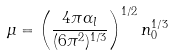Convert formula to latex. <formula><loc_0><loc_0><loc_500><loc_500>\mu = \left ( \frac { 4 \pi \alpha _ { l } } { ( 6 \pi ^ { 2 } ) ^ { 1 / 3 } } \right ) ^ { 1 / 2 } n _ { 0 } ^ { 1 / 3 }</formula> 